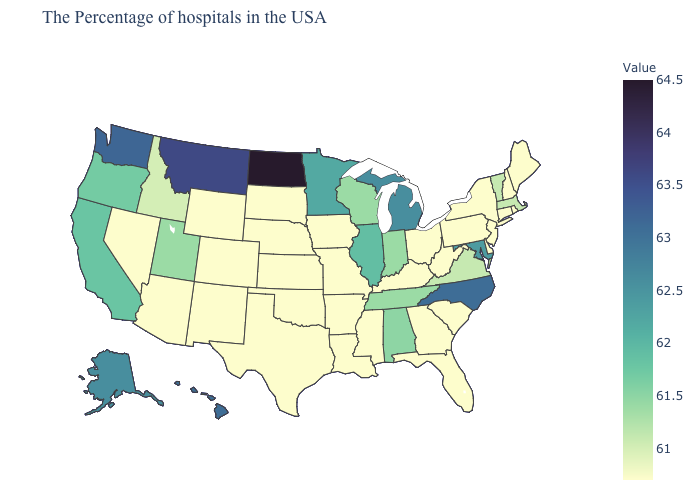Which states have the lowest value in the South?
Quick response, please. Delaware, South Carolina, West Virginia, Florida, Georgia, Kentucky, Mississippi, Louisiana, Arkansas, Oklahoma, Texas. Among the states that border Kentucky , which have the lowest value?
Keep it brief. West Virginia, Ohio, Missouri. Among the states that border Kentucky , does Virginia have the highest value?
Concise answer only. No. Among the states that border Florida , does Alabama have the lowest value?
Keep it brief. No. 